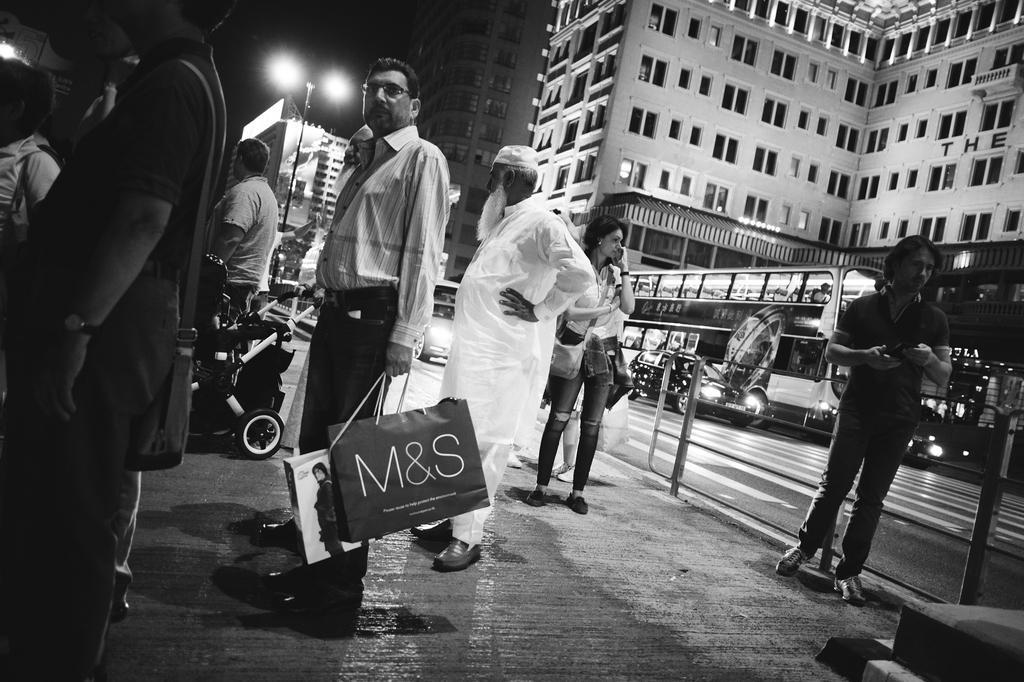Describe this image in one or two sentences. In this picture I can see there are few men standing and few of them are holding carry bags, there is a woman, she is standing and is speaking. There is a road on right side and there are few vehicles moving on the road and there is a road, there is a pole with lights and the sky is dark. This is a black and white image. 